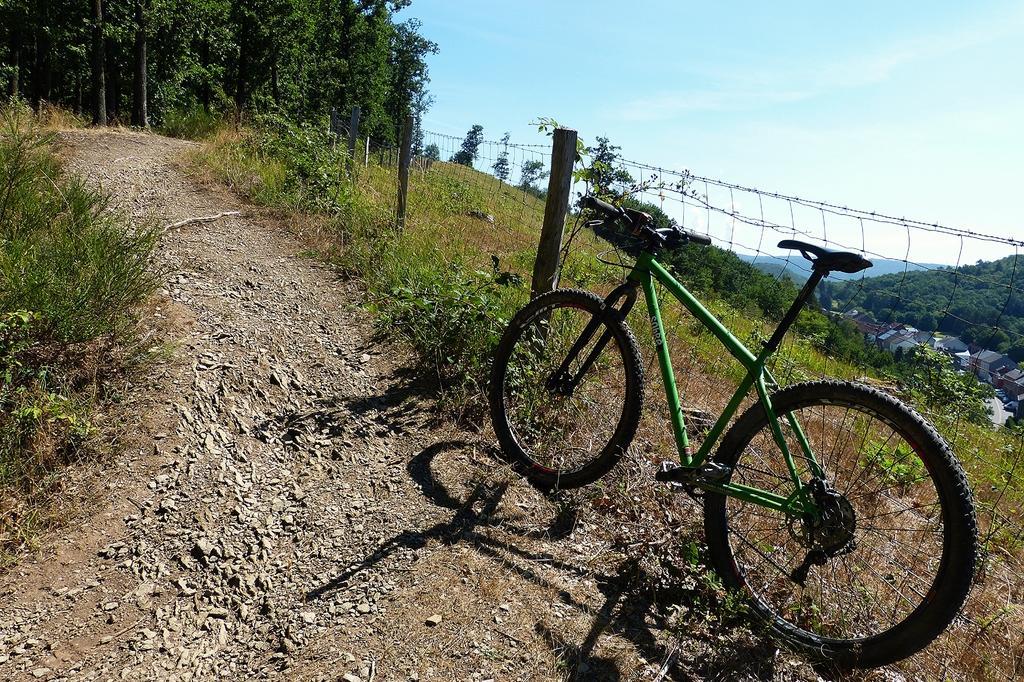How would you summarize this image in a sentence or two? As we can see in the image there is a bicycle, grass, trees, hills and sky. 